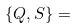Convert formula to latex. <formula><loc_0><loc_0><loc_500><loc_500>\{ Q , S \} =</formula> 